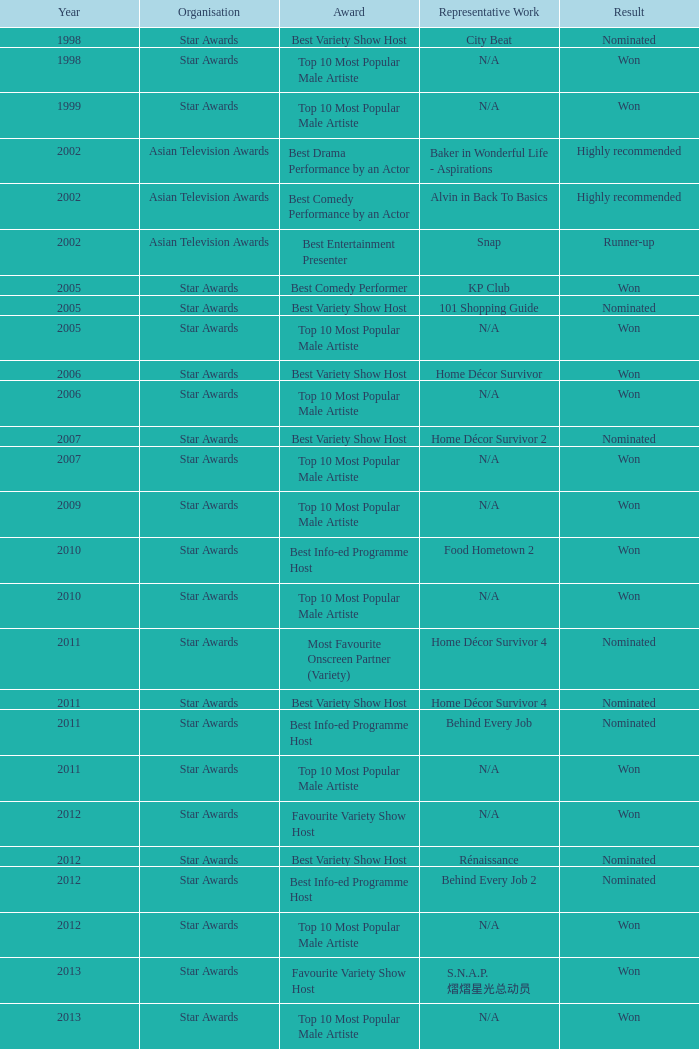What is the award for 1998 with Representative Work of city beat? Best Variety Show Host. 